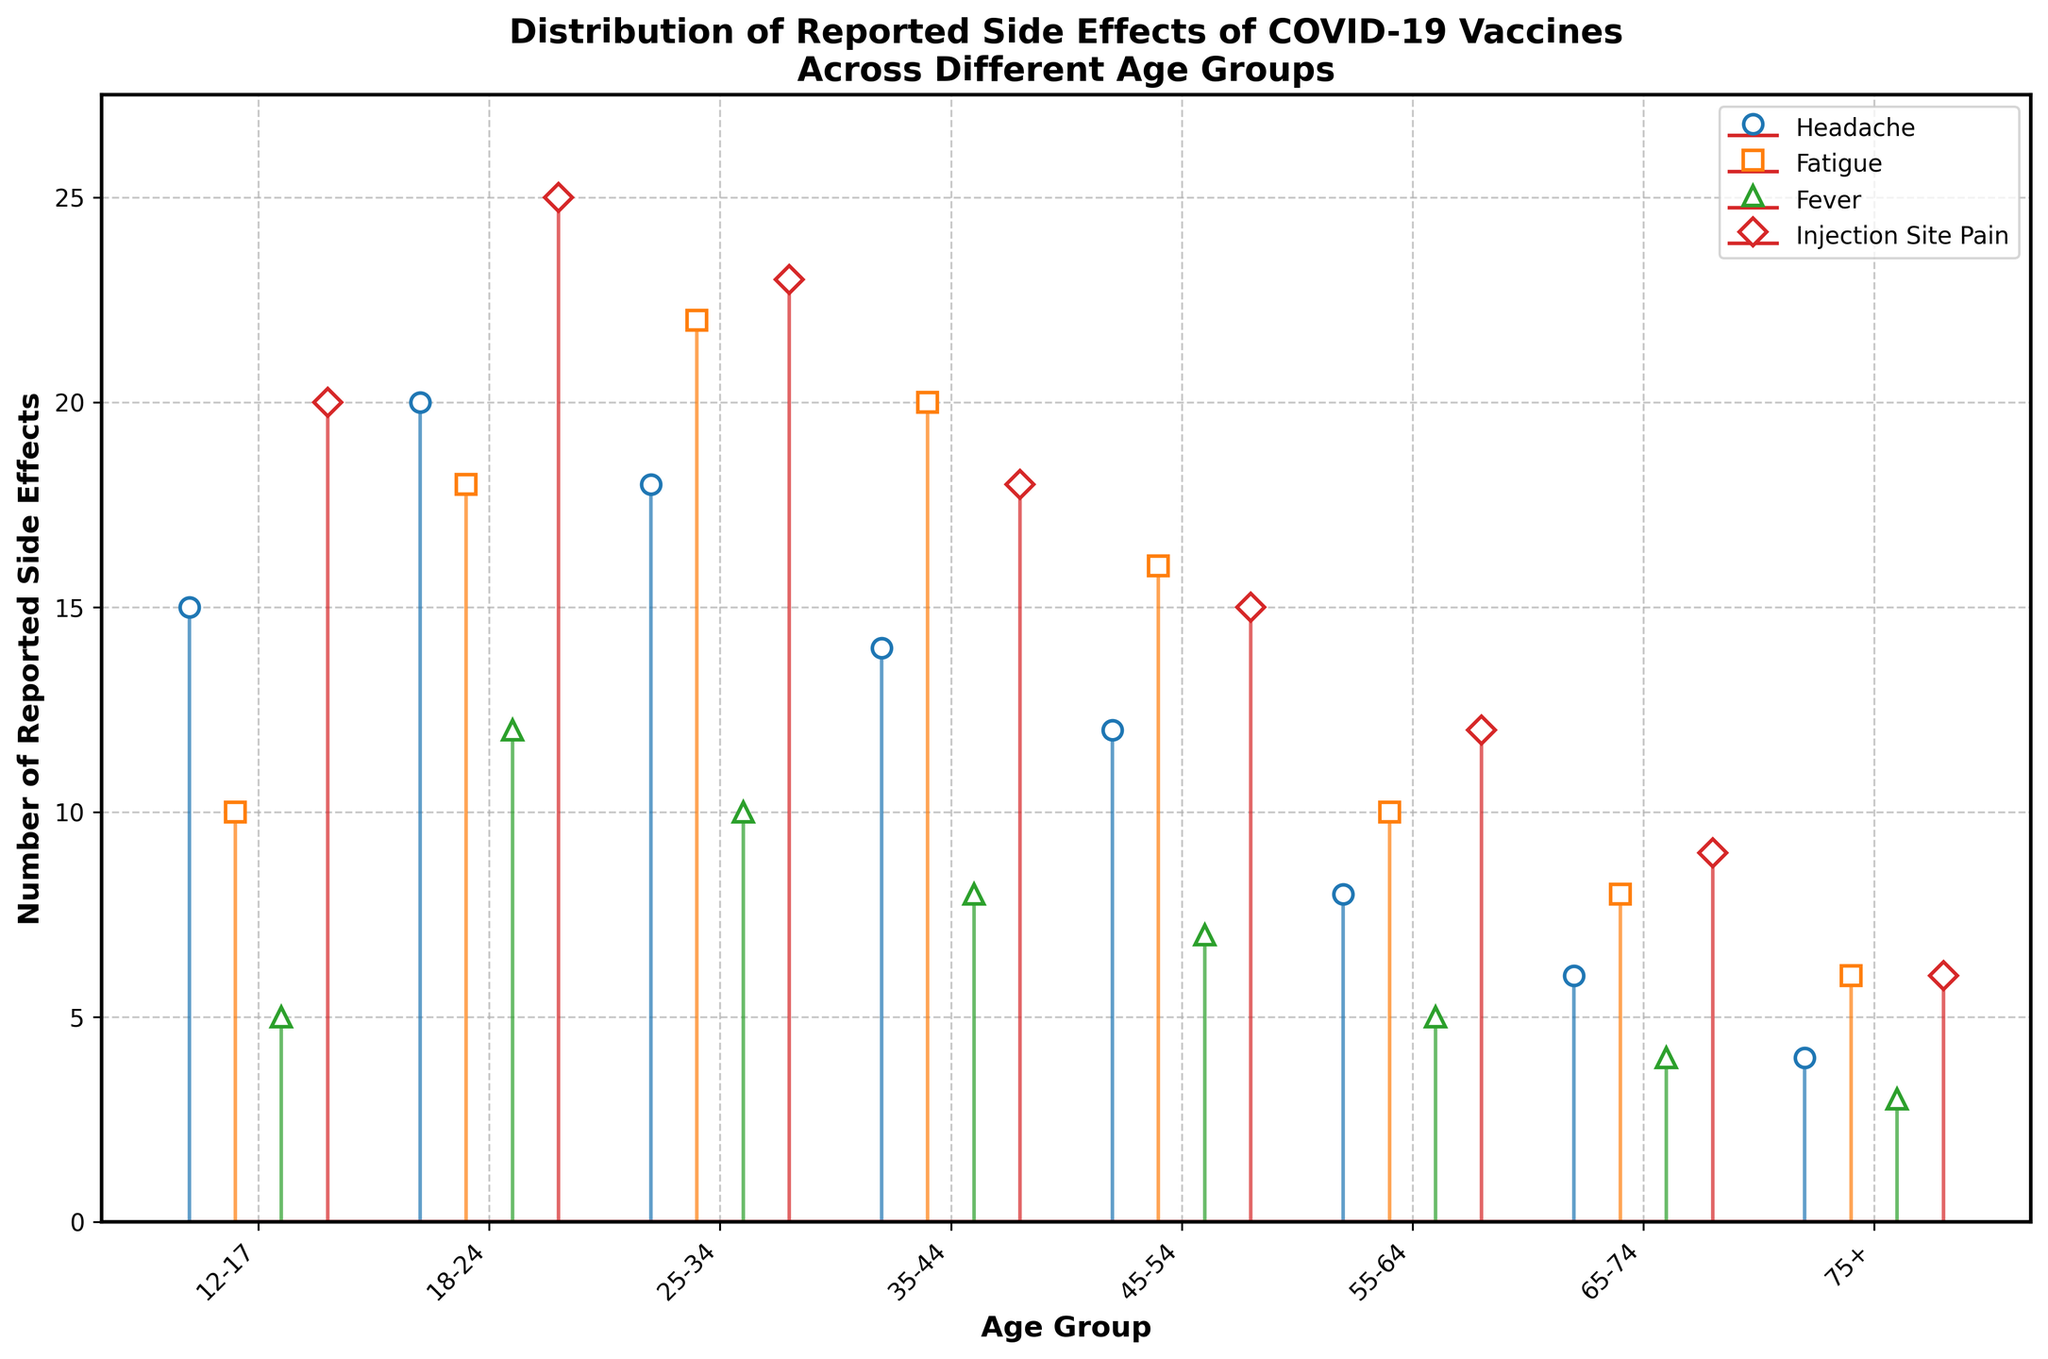What's the highest number of reported side effects for headache and in which age group? The stem plot shows the number of reported headaches by age group. The highest number of headaches appears as the tallest stem for the corresponding age group. By visual inspection, the highest stem is 20 in the 18-24 age group.
Answer: 20 in the 18-24 age group Which age group reported the fewest injection site pains? The number of reported injection site pains is represented by the 'D'-shaped markers in the plot. The fewest number of injection site pains is represented by the lowest stem. By visual inspection, the 75+ age group has the smallest stem with 6 cases.
Answer: 75+ age group How many age groups reported fatigue cases greater than 15? To find the number of age groups with more than 15 fatigue cases, we locate the 's'-shaped markers and count how many times they are above the 15 mark, which can be visualized on the y-axis. Age groups 18-24, 25-34, and 35-44 reported more than 15 cases of fatigue.
Answer: 3 age groups What is the average number of fever cases reported across all age groups? Add up the number of fever cases for all age groups: 5 (12-17) + 12 (18-24) + 10 (25-34) + 8 (35-44) + 7 (45-54) + 5 (55-64) + 4 (65-74) + 3 (75+), which totals 54. There are 8 age groups, so divide 54 by 8 to find the average.
Answer: 6.75 Compare the number of fatigue cases reported by the 18-24 and 35-44 age groups. Which is higher? By looking at the stem plot, we compare the heights of the 's'-shaped markers for these age groups. The 18-24 age group reported 18 cases of fatigue, while the 35-44 age group reported 20 cases.
Answer: 35-44 age group What is the combined total number of reported side effects (headache, fatigue, fever, injection site pain) for the 45-54 age group? Sum the number of reported cases for headache (12), fatigue (16), fever (7), and injection site pain (15) in the 45-54 age group. The total is 12 + 16 + 7 + 15 = 50.
Answer: 50 Which age group had the highest variation in side effects? Calculate the range for each age group (highest minus lowest reported side effect). Compare these ranges across age groups. For instance, 12-17: 20-5=15, 18-24: 25-12=13, etc. The highest variation is 12-17 age group with a range of 15.
Answer: 12-17 age group What's the trend in the number of reported injection site pains as age increases? Observe how the heights of the 'D'-shaped markers change from left (younger age groups) to right (older age groups). The trend shows a decreasing number of injection site pains as age increases.
Answer: Decreasing Compare the summed-up reported side effects of headache, fatigue, fever, and injection site pain between the 55-64 and 65-74 age groups. Which group has more total reported cases? Calculate the sums for both age groups. For 55-64: 8 (headache) + 10 (fatigue) + 5 (fever) + 12 (injection site pain) = 35. For 65-74: 6 (headache) + 8 (fatigue) + 4 (fever) + 9 (injection site pain) = 27.
Answer: 55-64 age group 